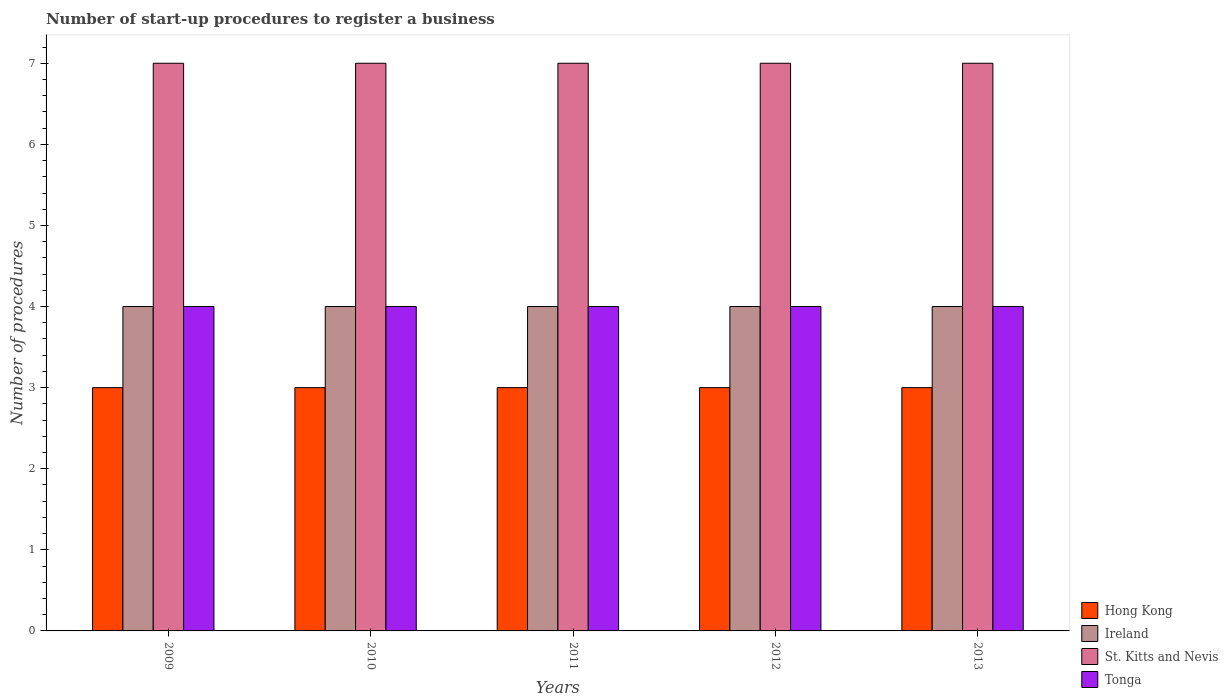How many different coloured bars are there?
Provide a succinct answer. 4. How many groups of bars are there?
Keep it short and to the point. 5. What is the number of procedures required to register a business in Ireland in 2011?
Offer a very short reply. 4. Across all years, what is the maximum number of procedures required to register a business in Tonga?
Give a very brief answer. 4. Across all years, what is the minimum number of procedures required to register a business in Ireland?
Ensure brevity in your answer.  4. In which year was the number of procedures required to register a business in Hong Kong maximum?
Offer a very short reply. 2009. What is the total number of procedures required to register a business in Hong Kong in the graph?
Your answer should be very brief. 15. What is the ratio of the number of procedures required to register a business in Hong Kong in 2009 to that in 2013?
Offer a terse response. 1. Is the difference between the number of procedures required to register a business in Tonga in 2010 and 2012 greater than the difference between the number of procedures required to register a business in Ireland in 2010 and 2012?
Your answer should be very brief. No. What is the difference between the highest and the lowest number of procedures required to register a business in Ireland?
Offer a terse response. 0. In how many years, is the number of procedures required to register a business in Hong Kong greater than the average number of procedures required to register a business in Hong Kong taken over all years?
Your response must be concise. 0. What does the 3rd bar from the left in 2013 represents?
Offer a very short reply. St. Kitts and Nevis. What does the 1st bar from the right in 2010 represents?
Your answer should be compact. Tonga. How many bars are there?
Your answer should be very brief. 20. Are all the bars in the graph horizontal?
Provide a succinct answer. No. Does the graph contain grids?
Your response must be concise. No. What is the title of the graph?
Provide a short and direct response. Number of start-up procedures to register a business. Does "San Marino" appear as one of the legend labels in the graph?
Ensure brevity in your answer.  No. What is the label or title of the Y-axis?
Provide a short and direct response. Number of procedures. What is the Number of procedures of Ireland in 2009?
Provide a succinct answer. 4. What is the Number of procedures of St. Kitts and Nevis in 2009?
Provide a short and direct response. 7. What is the Number of procedures in Ireland in 2010?
Provide a succinct answer. 4. What is the Number of procedures of St. Kitts and Nevis in 2010?
Make the answer very short. 7. What is the Number of procedures of Ireland in 2011?
Your response must be concise. 4. What is the Number of procedures of Tonga in 2011?
Your answer should be very brief. 4. What is the Number of procedures in Hong Kong in 2012?
Your answer should be very brief. 3. What is the Number of procedures in Ireland in 2012?
Provide a succinct answer. 4. What is the Number of procedures in St. Kitts and Nevis in 2012?
Give a very brief answer. 7. What is the Number of procedures of St. Kitts and Nevis in 2013?
Your response must be concise. 7. What is the Number of procedures of Tonga in 2013?
Provide a succinct answer. 4. Across all years, what is the maximum Number of procedures of Hong Kong?
Your response must be concise. 3. Across all years, what is the maximum Number of procedures in Ireland?
Your answer should be very brief. 4. Across all years, what is the maximum Number of procedures of St. Kitts and Nevis?
Offer a very short reply. 7. Across all years, what is the maximum Number of procedures of Tonga?
Your response must be concise. 4. Across all years, what is the minimum Number of procedures in Ireland?
Your answer should be very brief. 4. Across all years, what is the minimum Number of procedures in St. Kitts and Nevis?
Make the answer very short. 7. Across all years, what is the minimum Number of procedures in Tonga?
Provide a succinct answer. 4. What is the total Number of procedures of Ireland in the graph?
Offer a very short reply. 20. What is the total Number of procedures of St. Kitts and Nevis in the graph?
Offer a very short reply. 35. What is the difference between the Number of procedures in Hong Kong in 2009 and that in 2010?
Make the answer very short. 0. What is the difference between the Number of procedures of St. Kitts and Nevis in 2009 and that in 2010?
Keep it short and to the point. 0. What is the difference between the Number of procedures in Tonga in 2009 and that in 2010?
Provide a succinct answer. 0. What is the difference between the Number of procedures in Hong Kong in 2009 and that in 2011?
Give a very brief answer. 0. What is the difference between the Number of procedures of St. Kitts and Nevis in 2009 and that in 2011?
Ensure brevity in your answer.  0. What is the difference between the Number of procedures in Tonga in 2009 and that in 2011?
Ensure brevity in your answer.  0. What is the difference between the Number of procedures in Hong Kong in 2009 and that in 2012?
Offer a terse response. 0. What is the difference between the Number of procedures in St. Kitts and Nevis in 2009 and that in 2012?
Your answer should be compact. 0. What is the difference between the Number of procedures of St. Kitts and Nevis in 2009 and that in 2013?
Offer a very short reply. 0. What is the difference between the Number of procedures in Tonga in 2009 and that in 2013?
Ensure brevity in your answer.  0. What is the difference between the Number of procedures in Hong Kong in 2010 and that in 2011?
Make the answer very short. 0. What is the difference between the Number of procedures of Ireland in 2010 and that in 2012?
Your answer should be very brief. 0. What is the difference between the Number of procedures in St. Kitts and Nevis in 2010 and that in 2012?
Ensure brevity in your answer.  0. What is the difference between the Number of procedures of Tonga in 2010 and that in 2012?
Provide a short and direct response. 0. What is the difference between the Number of procedures of Ireland in 2010 and that in 2013?
Ensure brevity in your answer.  0. What is the difference between the Number of procedures in Tonga in 2010 and that in 2013?
Make the answer very short. 0. What is the difference between the Number of procedures of Hong Kong in 2011 and that in 2012?
Your answer should be compact. 0. What is the difference between the Number of procedures in Ireland in 2011 and that in 2012?
Give a very brief answer. 0. What is the difference between the Number of procedures of Tonga in 2011 and that in 2012?
Your response must be concise. 0. What is the difference between the Number of procedures of Hong Kong in 2011 and that in 2013?
Keep it short and to the point. 0. What is the difference between the Number of procedures in St. Kitts and Nevis in 2011 and that in 2013?
Offer a very short reply. 0. What is the difference between the Number of procedures in Hong Kong in 2012 and that in 2013?
Provide a succinct answer. 0. What is the difference between the Number of procedures of St. Kitts and Nevis in 2012 and that in 2013?
Offer a very short reply. 0. What is the difference between the Number of procedures of Hong Kong in 2009 and the Number of procedures of Tonga in 2010?
Provide a short and direct response. -1. What is the difference between the Number of procedures of Ireland in 2009 and the Number of procedures of St. Kitts and Nevis in 2010?
Your response must be concise. -3. What is the difference between the Number of procedures in Hong Kong in 2009 and the Number of procedures in St. Kitts and Nevis in 2011?
Your response must be concise. -4. What is the difference between the Number of procedures of Ireland in 2009 and the Number of procedures of St. Kitts and Nevis in 2011?
Your response must be concise. -3. What is the difference between the Number of procedures of St. Kitts and Nevis in 2009 and the Number of procedures of Tonga in 2011?
Offer a very short reply. 3. What is the difference between the Number of procedures of Hong Kong in 2009 and the Number of procedures of Ireland in 2012?
Provide a succinct answer. -1. What is the difference between the Number of procedures in Hong Kong in 2009 and the Number of procedures in Ireland in 2013?
Your response must be concise. -1. What is the difference between the Number of procedures of Hong Kong in 2009 and the Number of procedures of St. Kitts and Nevis in 2013?
Your answer should be very brief. -4. What is the difference between the Number of procedures in Hong Kong in 2009 and the Number of procedures in Tonga in 2013?
Ensure brevity in your answer.  -1. What is the difference between the Number of procedures in Ireland in 2009 and the Number of procedures in St. Kitts and Nevis in 2013?
Your answer should be compact. -3. What is the difference between the Number of procedures of Ireland in 2009 and the Number of procedures of Tonga in 2013?
Provide a succinct answer. 0. What is the difference between the Number of procedures in St. Kitts and Nevis in 2009 and the Number of procedures in Tonga in 2013?
Your response must be concise. 3. What is the difference between the Number of procedures in Hong Kong in 2010 and the Number of procedures in Ireland in 2011?
Offer a very short reply. -1. What is the difference between the Number of procedures in Hong Kong in 2010 and the Number of procedures in St. Kitts and Nevis in 2011?
Make the answer very short. -4. What is the difference between the Number of procedures in Hong Kong in 2010 and the Number of procedures in Tonga in 2011?
Provide a short and direct response. -1. What is the difference between the Number of procedures in St. Kitts and Nevis in 2010 and the Number of procedures in Tonga in 2011?
Ensure brevity in your answer.  3. What is the difference between the Number of procedures of Hong Kong in 2010 and the Number of procedures of St. Kitts and Nevis in 2012?
Your answer should be very brief. -4. What is the difference between the Number of procedures in Hong Kong in 2010 and the Number of procedures in Tonga in 2012?
Ensure brevity in your answer.  -1. What is the difference between the Number of procedures in Ireland in 2010 and the Number of procedures in St. Kitts and Nevis in 2012?
Give a very brief answer. -3. What is the difference between the Number of procedures of Ireland in 2010 and the Number of procedures of Tonga in 2012?
Give a very brief answer. 0. What is the difference between the Number of procedures in St. Kitts and Nevis in 2010 and the Number of procedures in Tonga in 2012?
Offer a terse response. 3. What is the difference between the Number of procedures in Hong Kong in 2010 and the Number of procedures in Ireland in 2013?
Your answer should be very brief. -1. What is the difference between the Number of procedures in Hong Kong in 2010 and the Number of procedures in St. Kitts and Nevis in 2013?
Ensure brevity in your answer.  -4. What is the difference between the Number of procedures of Hong Kong in 2010 and the Number of procedures of Tonga in 2013?
Ensure brevity in your answer.  -1. What is the difference between the Number of procedures of Ireland in 2010 and the Number of procedures of St. Kitts and Nevis in 2013?
Provide a short and direct response. -3. What is the difference between the Number of procedures in Ireland in 2010 and the Number of procedures in Tonga in 2013?
Keep it short and to the point. 0. What is the difference between the Number of procedures of Hong Kong in 2011 and the Number of procedures of Ireland in 2012?
Offer a very short reply. -1. What is the difference between the Number of procedures of Hong Kong in 2011 and the Number of procedures of St. Kitts and Nevis in 2012?
Your response must be concise. -4. What is the difference between the Number of procedures in Hong Kong in 2011 and the Number of procedures in Ireland in 2013?
Provide a succinct answer. -1. What is the difference between the Number of procedures in Hong Kong in 2011 and the Number of procedures in Tonga in 2013?
Provide a succinct answer. -1. What is the difference between the Number of procedures in Ireland in 2011 and the Number of procedures in St. Kitts and Nevis in 2013?
Offer a terse response. -3. What is the difference between the Number of procedures in Ireland in 2011 and the Number of procedures in Tonga in 2013?
Keep it short and to the point. 0. What is the difference between the Number of procedures in St. Kitts and Nevis in 2011 and the Number of procedures in Tonga in 2013?
Provide a succinct answer. 3. What is the difference between the Number of procedures of Hong Kong in 2012 and the Number of procedures of St. Kitts and Nevis in 2013?
Make the answer very short. -4. What is the difference between the Number of procedures in Ireland in 2012 and the Number of procedures in Tonga in 2013?
Your answer should be compact. 0. What is the average Number of procedures of Hong Kong per year?
Keep it short and to the point. 3. What is the average Number of procedures in Ireland per year?
Your response must be concise. 4. What is the average Number of procedures of Tonga per year?
Give a very brief answer. 4. In the year 2009, what is the difference between the Number of procedures in Hong Kong and Number of procedures in Ireland?
Provide a succinct answer. -1. In the year 2009, what is the difference between the Number of procedures of Hong Kong and Number of procedures of St. Kitts and Nevis?
Provide a succinct answer. -4. In the year 2010, what is the difference between the Number of procedures in Hong Kong and Number of procedures in Ireland?
Provide a short and direct response. -1. In the year 2010, what is the difference between the Number of procedures of Hong Kong and Number of procedures of Tonga?
Offer a terse response. -1. In the year 2010, what is the difference between the Number of procedures in Ireland and Number of procedures in St. Kitts and Nevis?
Your answer should be very brief. -3. In the year 2010, what is the difference between the Number of procedures of Ireland and Number of procedures of Tonga?
Give a very brief answer. 0. In the year 2011, what is the difference between the Number of procedures of Hong Kong and Number of procedures of St. Kitts and Nevis?
Offer a very short reply. -4. In the year 2011, what is the difference between the Number of procedures in Hong Kong and Number of procedures in Tonga?
Offer a very short reply. -1. In the year 2011, what is the difference between the Number of procedures of Ireland and Number of procedures of Tonga?
Make the answer very short. 0. In the year 2011, what is the difference between the Number of procedures in St. Kitts and Nevis and Number of procedures in Tonga?
Keep it short and to the point. 3. In the year 2012, what is the difference between the Number of procedures of Hong Kong and Number of procedures of St. Kitts and Nevis?
Offer a very short reply. -4. In the year 2013, what is the difference between the Number of procedures of Hong Kong and Number of procedures of Ireland?
Your response must be concise. -1. In the year 2013, what is the difference between the Number of procedures of Hong Kong and Number of procedures of St. Kitts and Nevis?
Provide a succinct answer. -4. In the year 2013, what is the difference between the Number of procedures of Ireland and Number of procedures of St. Kitts and Nevis?
Offer a terse response. -3. What is the ratio of the Number of procedures in Ireland in 2009 to that in 2010?
Give a very brief answer. 1. What is the ratio of the Number of procedures of Tonga in 2009 to that in 2010?
Make the answer very short. 1. What is the ratio of the Number of procedures in Hong Kong in 2009 to that in 2011?
Provide a succinct answer. 1. What is the ratio of the Number of procedures of Ireland in 2009 to that in 2011?
Offer a very short reply. 1. What is the ratio of the Number of procedures of Tonga in 2009 to that in 2011?
Provide a succinct answer. 1. What is the ratio of the Number of procedures in Hong Kong in 2009 to that in 2012?
Offer a very short reply. 1. What is the ratio of the Number of procedures in Ireland in 2009 to that in 2013?
Ensure brevity in your answer.  1. What is the ratio of the Number of procedures in Tonga in 2009 to that in 2013?
Make the answer very short. 1. What is the ratio of the Number of procedures in Ireland in 2010 to that in 2011?
Give a very brief answer. 1. What is the ratio of the Number of procedures in Tonga in 2010 to that in 2011?
Provide a succinct answer. 1. What is the ratio of the Number of procedures in St. Kitts and Nevis in 2010 to that in 2012?
Your answer should be compact. 1. What is the ratio of the Number of procedures of Tonga in 2010 to that in 2012?
Make the answer very short. 1. What is the ratio of the Number of procedures in Hong Kong in 2010 to that in 2013?
Make the answer very short. 1. What is the ratio of the Number of procedures of Ireland in 2010 to that in 2013?
Offer a very short reply. 1. What is the ratio of the Number of procedures in Tonga in 2010 to that in 2013?
Your answer should be very brief. 1. What is the ratio of the Number of procedures in Hong Kong in 2011 to that in 2012?
Ensure brevity in your answer.  1. What is the ratio of the Number of procedures of Ireland in 2011 to that in 2012?
Your answer should be very brief. 1. What is the ratio of the Number of procedures of St. Kitts and Nevis in 2011 to that in 2012?
Your response must be concise. 1. What is the ratio of the Number of procedures in St. Kitts and Nevis in 2011 to that in 2013?
Offer a terse response. 1. What is the difference between the highest and the second highest Number of procedures in Hong Kong?
Ensure brevity in your answer.  0. What is the difference between the highest and the second highest Number of procedures of Tonga?
Keep it short and to the point. 0. What is the difference between the highest and the lowest Number of procedures in Hong Kong?
Make the answer very short. 0. What is the difference between the highest and the lowest Number of procedures in Ireland?
Your response must be concise. 0. What is the difference between the highest and the lowest Number of procedures of Tonga?
Your answer should be compact. 0. 